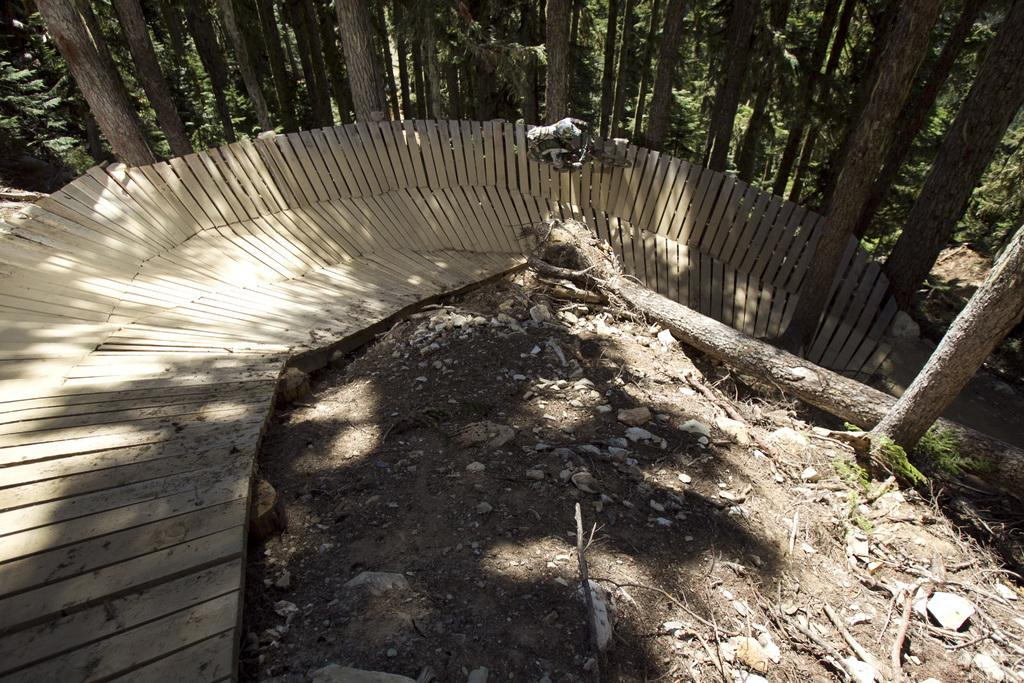What is the person in the image doing? The person is riding a bicycle. What surface is the person riding on? The person is riding on a wooden platform. What can be seen in the background of the image? There are trees in the background. What type of terrain is visible on the ground? Small stones are present on the ground. What color crayon is the person using to draw on the wooden platform? There is no crayon present in the image, and the person is riding a bicycle, not drawing. 